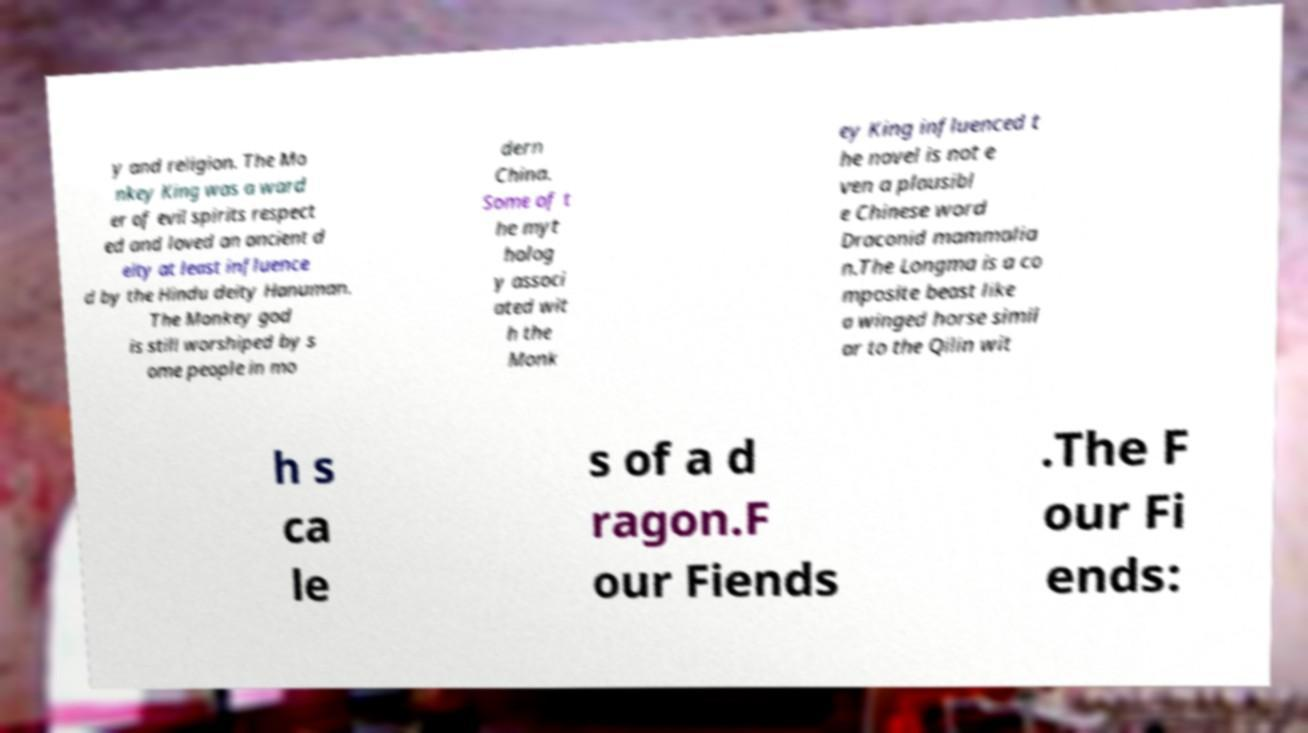Please read and relay the text visible in this image. What does it say? y and religion. The Mo nkey King was a ward er of evil spirits respect ed and loved an ancient d eity at least influence d by the Hindu deity Hanuman. The Monkey god is still worshiped by s ome people in mo dern China. Some of t he myt holog y associ ated wit h the Monk ey King influenced t he novel is not e ven a plausibl e Chinese word Draconid mammalia n.The Longma is a co mposite beast like a winged horse simil ar to the Qilin wit h s ca le s of a d ragon.F our Fiends .The F our Fi ends: 